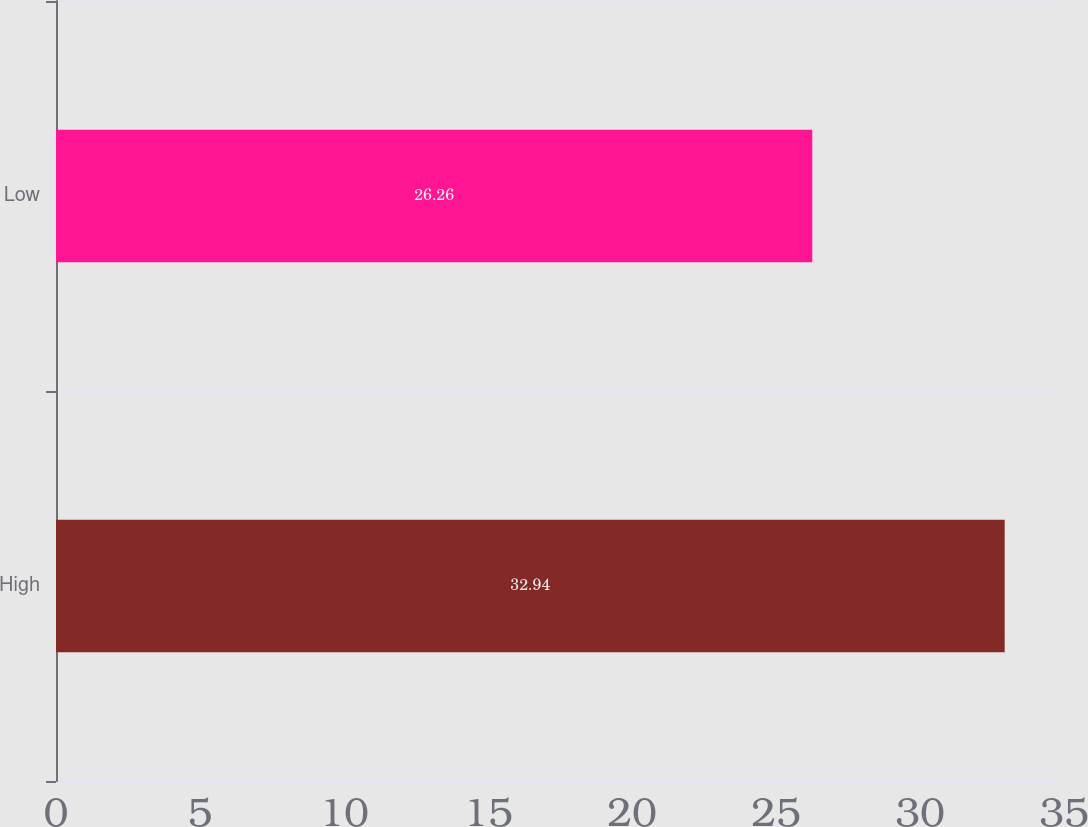<chart> <loc_0><loc_0><loc_500><loc_500><bar_chart><fcel>High<fcel>Low<nl><fcel>32.94<fcel>26.26<nl></chart> 